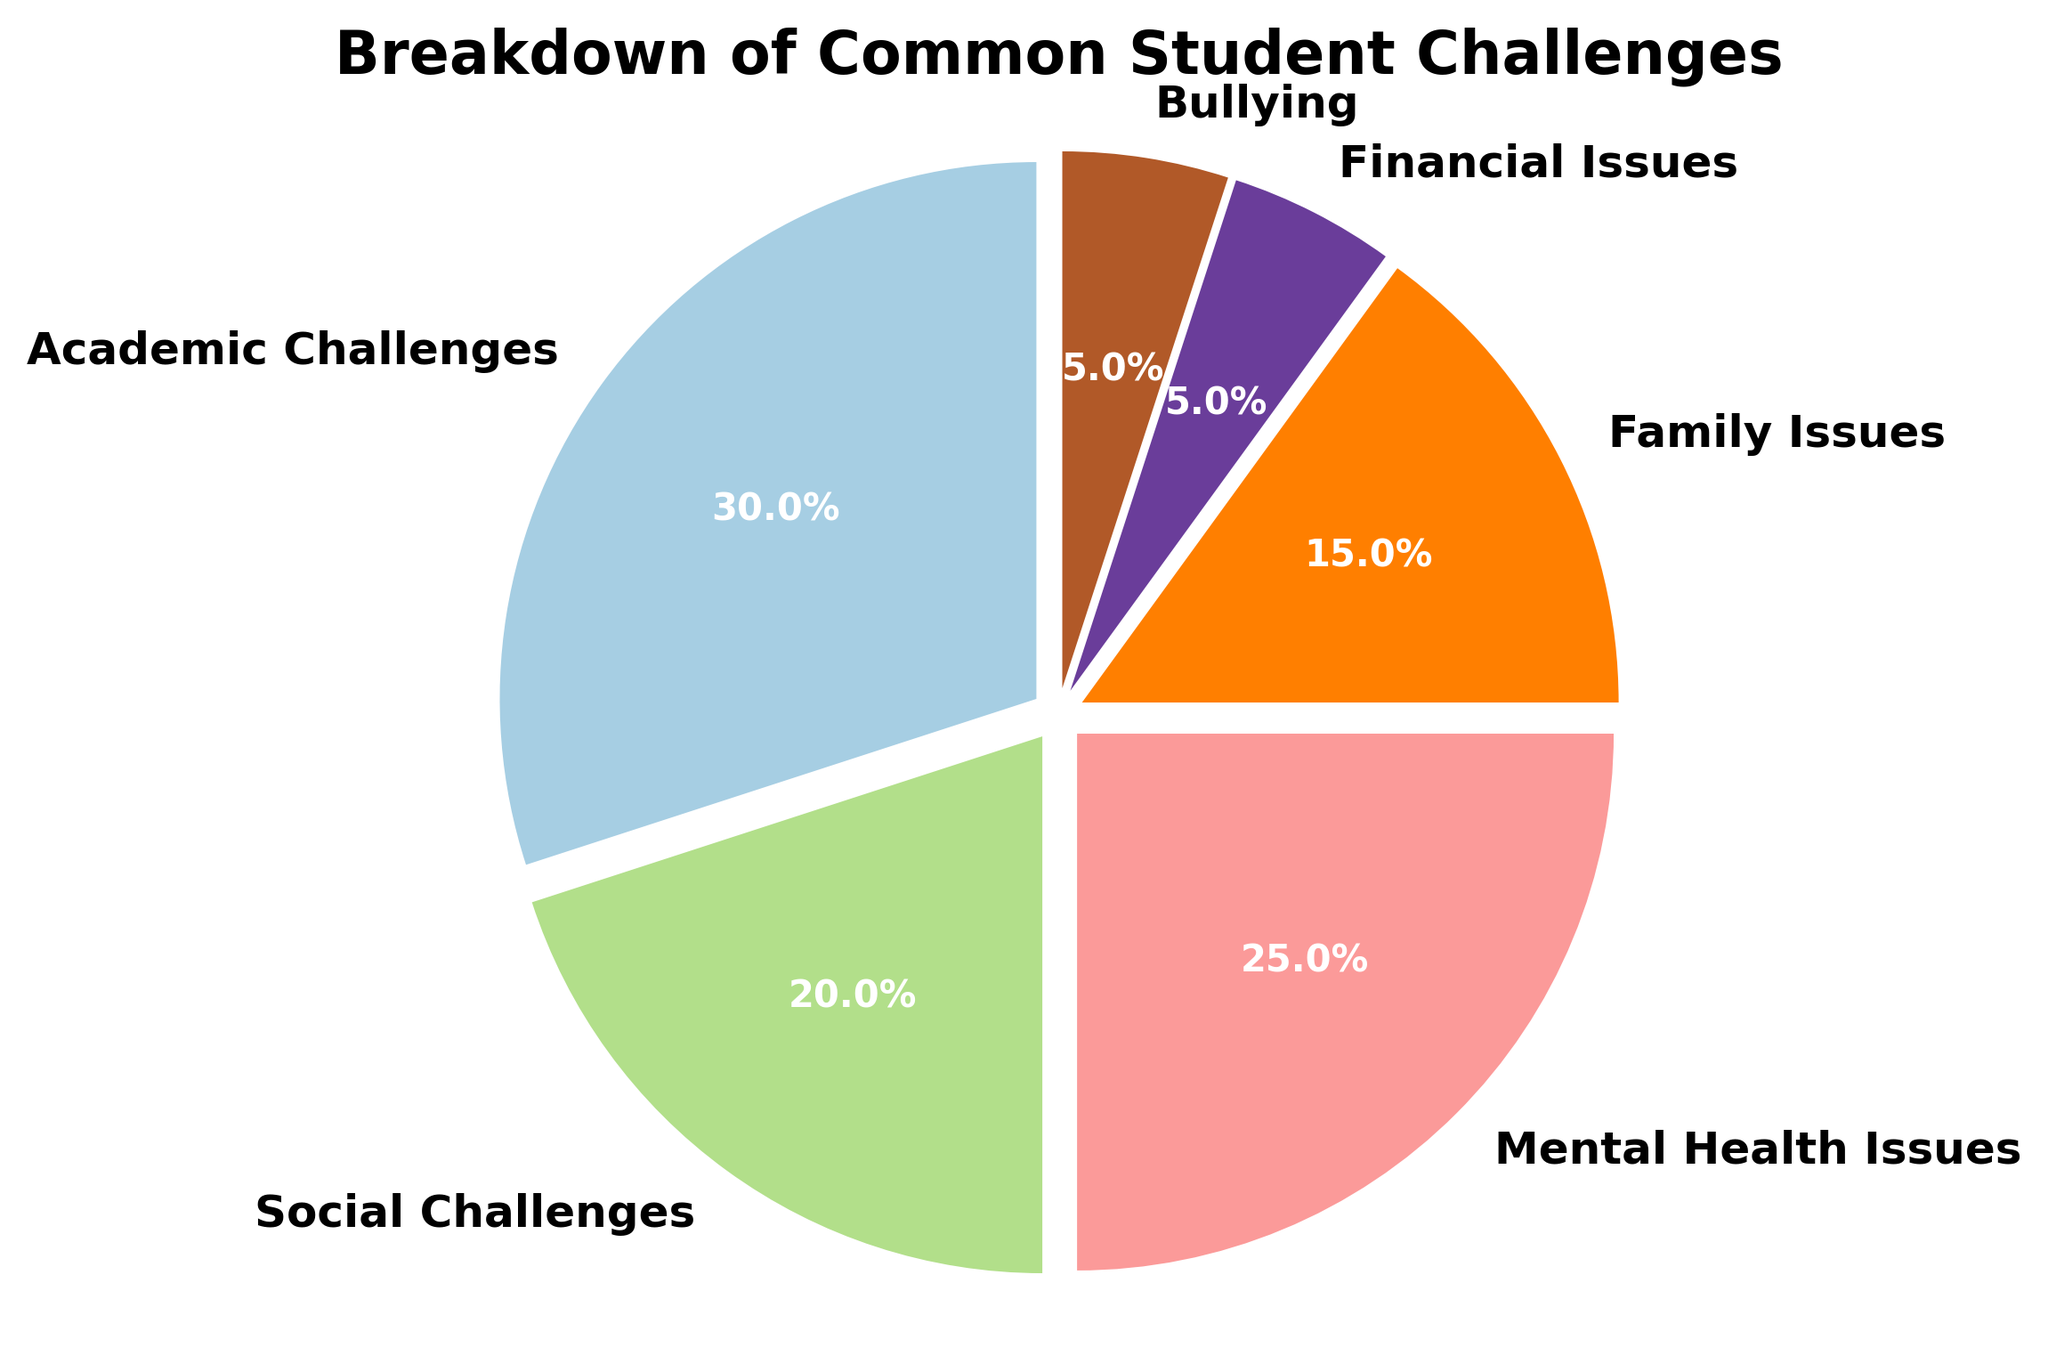What percentage of challenges are related to family issues? To find the percentage of challenges related to family issues, look at the segment labeled "Family Issues" in the pie chart.
Answer: 15% Which category has the highest percentage of challenges? To determine the category with the highest percentage of challenges, find the largest segment in the pie chart. The "Academic Challenges" segment is the largest.
Answer: Academic Challenges How does the percentage of academic challenges compare to social challenges? Compare the segments labeled "Academic Challenges" and "Social Challenges" in the pie chart. "Academic Challenges" is larger than "Social Challenges."
Answer: Academic Challenges > Social Challenges What is the combined percentage of mental health and family issues? Add the percentages of the "Mental Health Issues" and "Family Issues" segments: 25% + 15% = 40%.
Answer: 40% How much higher is the percentage of mental health issues compared to financial issues? Subtract the percentage of "Financial Issues" from "Mental Health Issues": 25% - 5% = 20%.
Answer: 20% What percentage of challenges fall into categories other than academic, social, and mental health? Add the percentages of "Family Issues," "Financial Issues," and "Bullying": 15% + 5% + 5% = 25%.
Answer: 25% What is the total percentage of challenges related to academic and social issues? Combine the percentages of "Academic Challenges" and "Social Challenges": 30% + 20% = 50%.
Answer: 50% Which categories have an equal percentage of challenges? Look for segments in the pie chart that have the same percentage. "Financial Issues" and "Bullying" both have 5%.
Answer: Financial Issues and Bullying What fraction of the pie chart is taken up by mental health issues? The percentage for "Mental Health Issues" is 25%, so the fraction is 25/100 or 1/4.
Answer: 1/4 